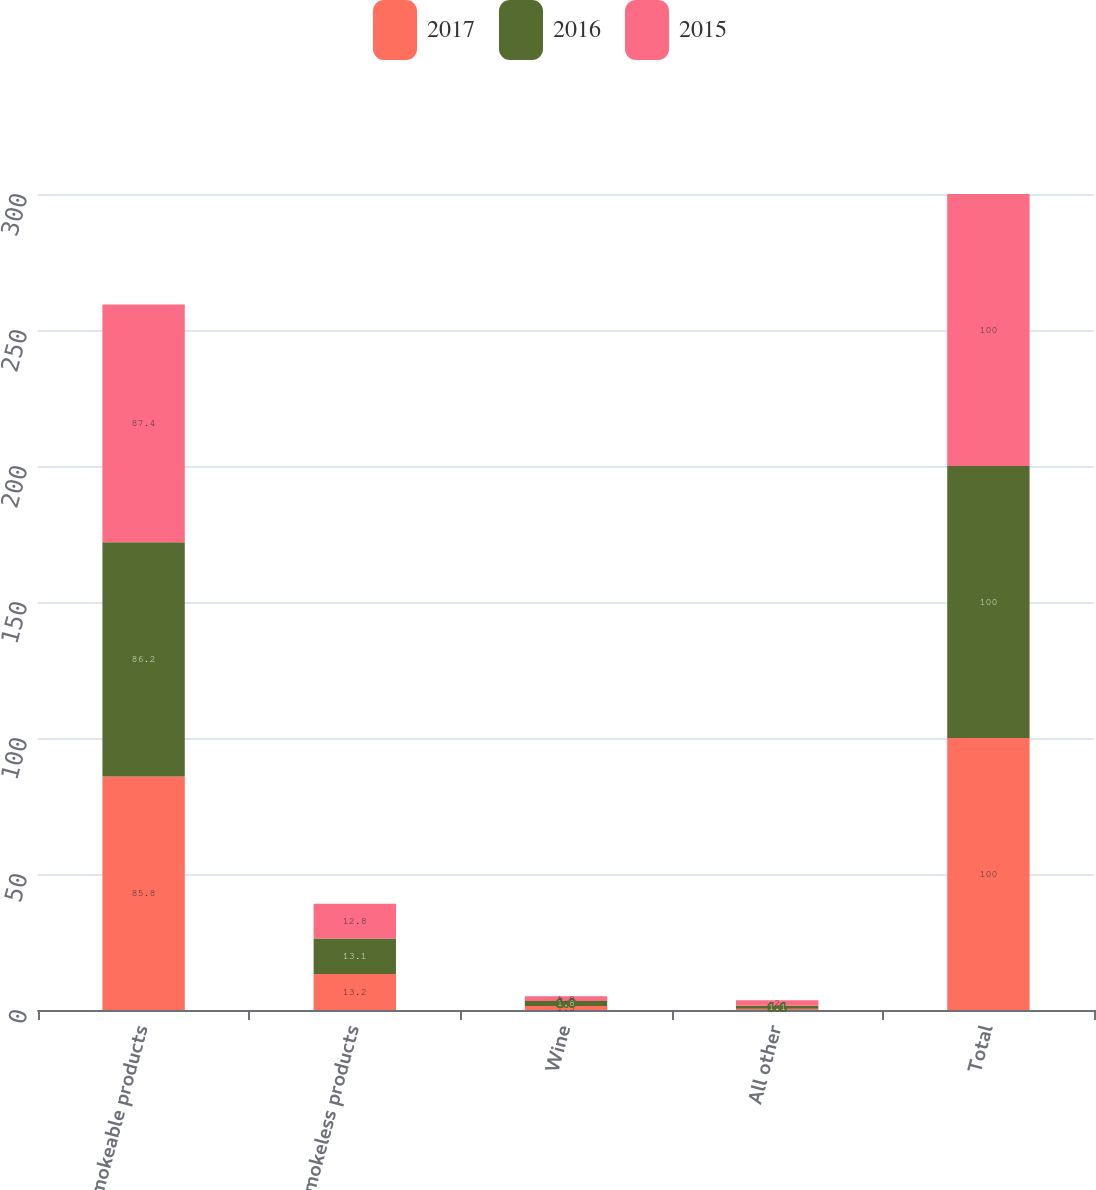<chart> <loc_0><loc_0><loc_500><loc_500><stacked_bar_chart><ecel><fcel>Smokeable products<fcel>Smokeless products<fcel>Wine<fcel>All other<fcel>Total<nl><fcel>2017<fcel>85.8<fcel>13.2<fcel>1.5<fcel>0.5<fcel>100<nl><fcel>2016<fcel>86.2<fcel>13.1<fcel>1.8<fcel>1.1<fcel>100<nl><fcel>2015<fcel>87.4<fcel>12.8<fcel>1.8<fcel>2<fcel>100<nl></chart> 